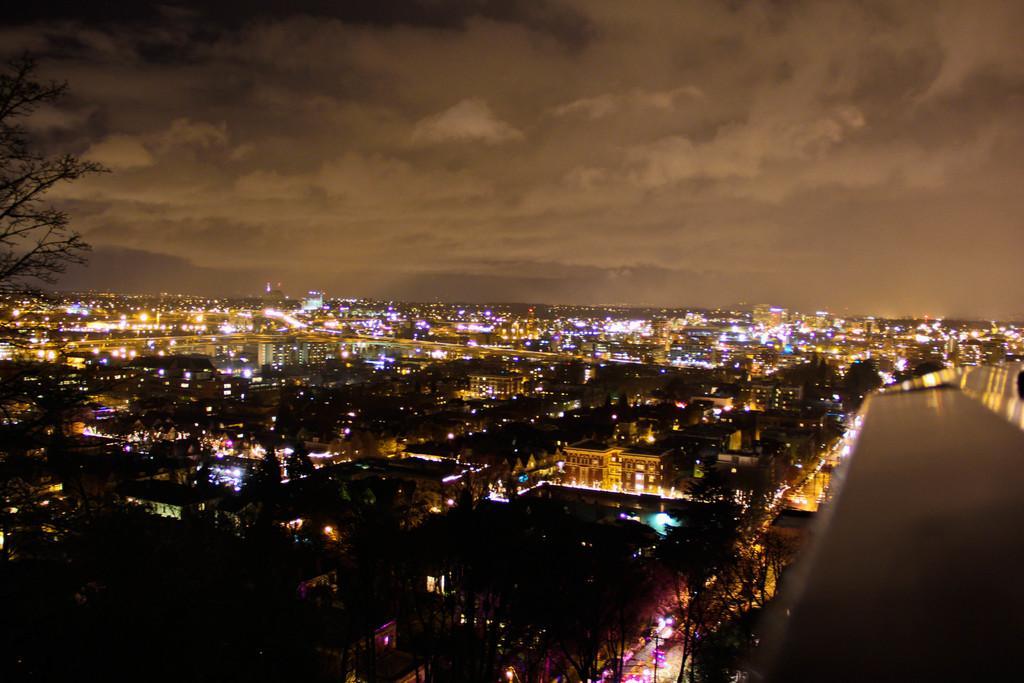Can you describe this image briefly? In this image there are trees, buildings, lights. At the top of the image there are clouds in the sky. 